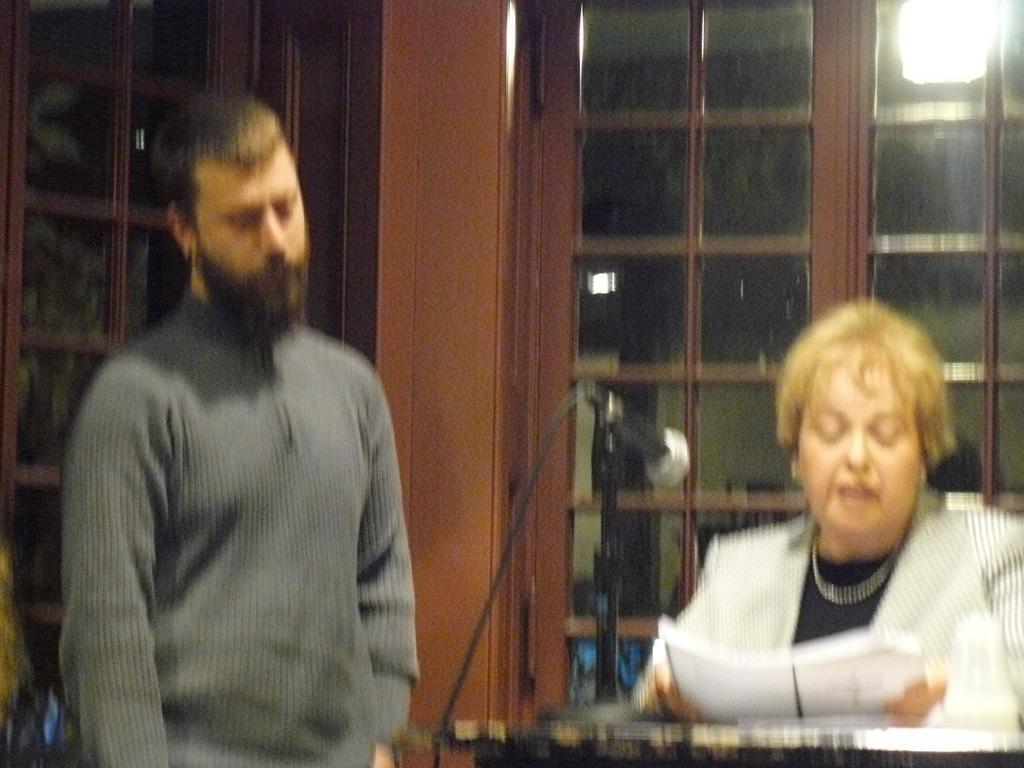Could you give a brief overview of what you see in this image? In this picture we can observe two members. One of them was a woman sitting in the chair in front of a table. There is a mic on the table and the other was a man standing beside her. In the background there is a door and a light. 